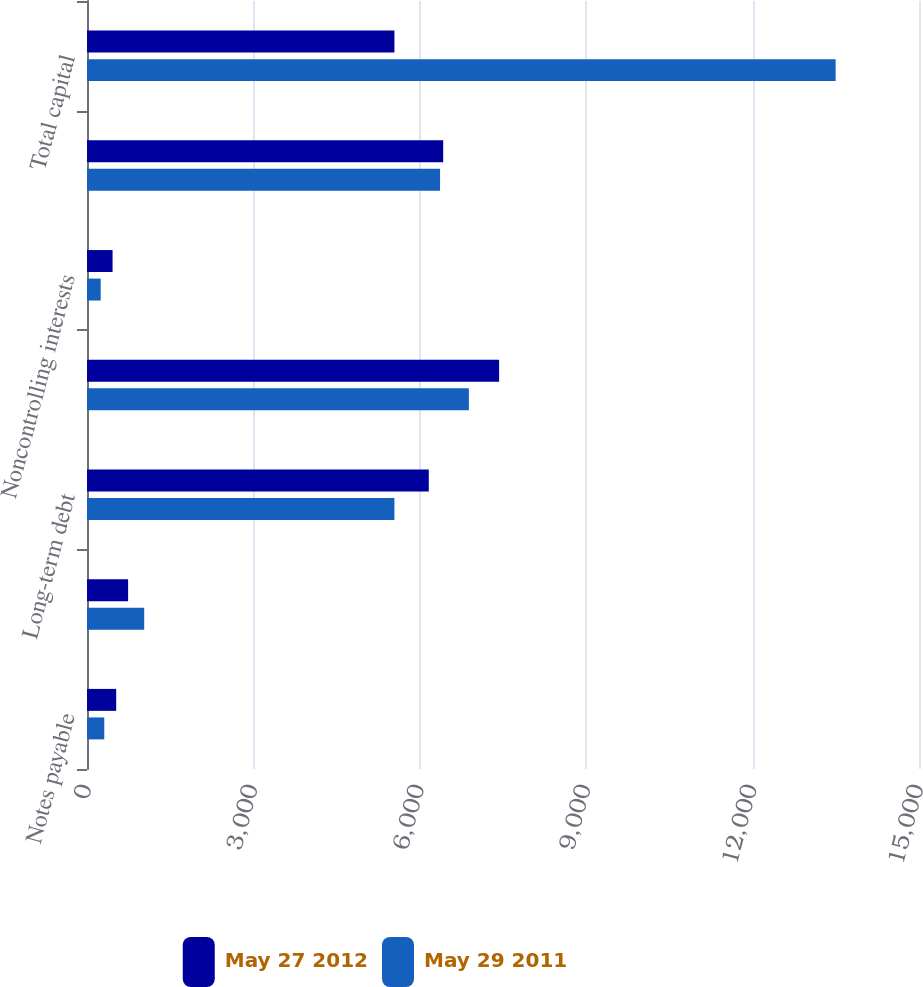<chart> <loc_0><loc_0><loc_500><loc_500><stacked_bar_chart><ecel><fcel>Notes payable<fcel>Current portion of long-term<fcel>Long-term debt<fcel>Total debt<fcel>Noncontrolling interests<fcel>Stockholders' equity<fcel>Total capital<nl><fcel>May 27 2012<fcel>526.5<fcel>741.2<fcel>6161.9<fcel>7429.6<fcel>461<fcel>6421.7<fcel>5542.5<nl><fcel>May 29 2011<fcel>311.3<fcel>1031.3<fcel>5542.5<fcel>6885.1<fcel>246.7<fcel>6365.5<fcel>13497.3<nl></chart> 